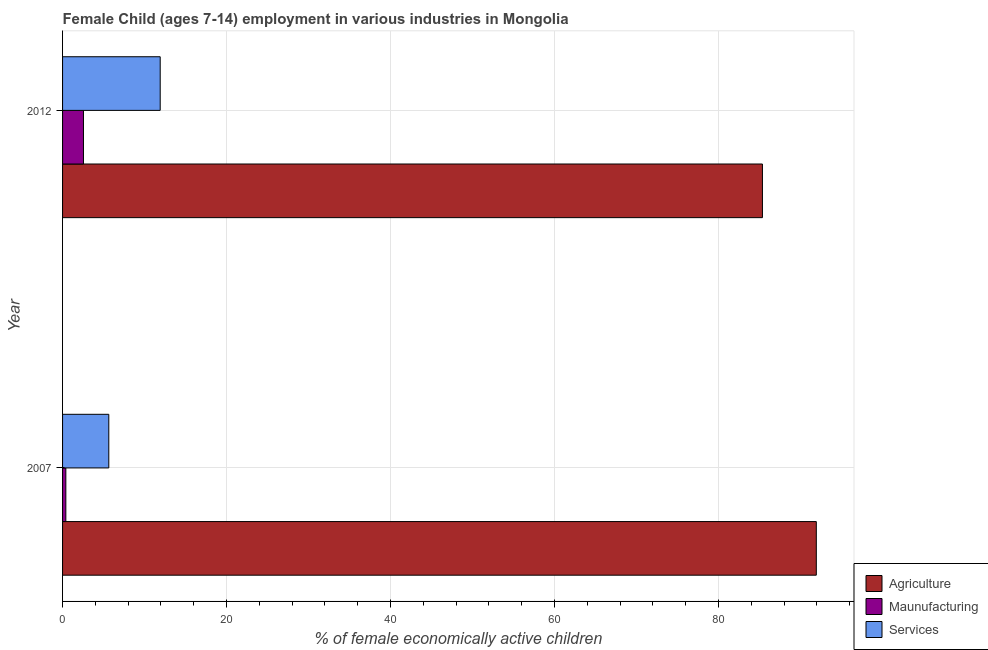Are the number of bars per tick equal to the number of legend labels?
Ensure brevity in your answer.  Yes. Are the number of bars on each tick of the Y-axis equal?
Provide a succinct answer. Yes. How many bars are there on the 1st tick from the bottom?
Your response must be concise. 3. What is the label of the 1st group of bars from the top?
Offer a very short reply. 2012. What is the percentage of economically active children in services in 2012?
Ensure brevity in your answer.  11.91. Across all years, what is the maximum percentage of economically active children in agriculture?
Ensure brevity in your answer.  91.94. In which year was the percentage of economically active children in agriculture maximum?
Your response must be concise. 2007. What is the total percentage of economically active children in agriculture in the graph?
Your response must be concise. 177.31. What is the difference between the percentage of economically active children in manufacturing in 2007 and that in 2012?
Keep it short and to the point. -2.15. What is the difference between the percentage of economically active children in services in 2007 and the percentage of economically active children in manufacturing in 2012?
Offer a terse response. 3.09. What is the average percentage of economically active children in manufacturing per year?
Offer a terse response. 1.48. In the year 2007, what is the difference between the percentage of economically active children in services and percentage of economically active children in agriculture?
Your response must be concise. -86.3. In how many years, is the percentage of economically active children in agriculture greater than 60 %?
Give a very brief answer. 2. What is the ratio of the percentage of economically active children in manufacturing in 2007 to that in 2012?
Your answer should be very brief. 0.16. What does the 1st bar from the top in 2012 represents?
Give a very brief answer. Services. What does the 2nd bar from the bottom in 2012 represents?
Offer a terse response. Maunufacturing. How many years are there in the graph?
Your answer should be very brief. 2. What is the difference between two consecutive major ticks on the X-axis?
Provide a short and direct response. 20. Are the values on the major ticks of X-axis written in scientific E-notation?
Your response must be concise. No. How many legend labels are there?
Your response must be concise. 3. How are the legend labels stacked?
Offer a very short reply. Vertical. What is the title of the graph?
Your response must be concise. Female Child (ages 7-14) employment in various industries in Mongolia. Does "Ages 0-14" appear as one of the legend labels in the graph?
Ensure brevity in your answer.  No. What is the label or title of the X-axis?
Your response must be concise. % of female economically active children. What is the label or title of the Y-axis?
Offer a very short reply. Year. What is the % of female economically active children in Agriculture in 2007?
Offer a terse response. 91.94. What is the % of female economically active children in Maunufacturing in 2007?
Ensure brevity in your answer.  0.4. What is the % of female economically active children of Services in 2007?
Make the answer very short. 5.64. What is the % of female economically active children of Agriculture in 2012?
Give a very brief answer. 85.37. What is the % of female economically active children in Maunufacturing in 2012?
Your answer should be very brief. 2.55. What is the % of female economically active children in Services in 2012?
Provide a short and direct response. 11.91. Across all years, what is the maximum % of female economically active children of Agriculture?
Keep it short and to the point. 91.94. Across all years, what is the maximum % of female economically active children of Maunufacturing?
Provide a short and direct response. 2.55. Across all years, what is the maximum % of female economically active children in Services?
Provide a short and direct response. 11.91. Across all years, what is the minimum % of female economically active children of Agriculture?
Offer a terse response. 85.37. Across all years, what is the minimum % of female economically active children of Maunufacturing?
Your answer should be very brief. 0.4. Across all years, what is the minimum % of female economically active children in Services?
Your response must be concise. 5.64. What is the total % of female economically active children in Agriculture in the graph?
Provide a succinct answer. 177.31. What is the total % of female economically active children of Maunufacturing in the graph?
Make the answer very short. 2.95. What is the total % of female economically active children of Services in the graph?
Keep it short and to the point. 17.55. What is the difference between the % of female economically active children of Agriculture in 2007 and that in 2012?
Make the answer very short. 6.57. What is the difference between the % of female economically active children in Maunufacturing in 2007 and that in 2012?
Offer a very short reply. -2.15. What is the difference between the % of female economically active children of Services in 2007 and that in 2012?
Give a very brief answer. -6.27. What is the difference between the % of female economically active children in Agriculture in 2007 and the % of female economically active children in Maunufacturing in 2012?
Your answer should be very brief. 89.39. What is the difference between the % of female economically active children in Agriculture in 2007 and the % of female economically active children in Services in 2012?
Offer a terse response. 80.03. What is the difference between the % of female economically active children of Maunufacturing in 2007 and the % of female economically active children of Services in 2012?
Your answer should be compact. -11.51. What is the average % of female economically active children of Agriculture per year?
Ensure brevity in your answer.  88.66. What is the average % of female economically active children of Maunufacturing per year?
Provide a succinct answer. 1.48. What is the average % of female economically active children of Services per year?
Your answer should be very brief. 8.78. In the year 2007, what is the difference between the % of female economically active children of Agriculture and % of female economically active children of Maunufacturing?
Offer a terse response. 91.54. In the year 2007, what is the difference between the % of female economically active children of Agriculture and % of female economically active children of Services?
Keep it short and to the point. 86.3. In the year 2007, what is the difference between the % of female economically active children of Maunufacturing and % of female economically active children of Services?
Offer a terse response. -5.24. In the year 2012, what is the difference between the % of female economically active children of Agriculture and % of female economically active children of Maunufacturing?
Make the answer very short. 82.82. In the year 2012, what is the difference between the % of female economically active children in Agriculture and % of female economically active children in Services?
Give a very brief answer. 73.46. In the year 2012, what is the difference between the % of female economically active children in Maunufacturing and % of female economically active children in Services?
Your answer should be very brief. -9.36. What is the ratio of the % of female economically active children in Agriculture in 2007 to that in 2012?
Make the answer very short. 1.08. What is the ratio of the % of female economically active children of Maunufacturing in 2007 to that in 2012?
Your response must be concise. 0.16. What is the ratio of the % of female economically active children of Services in 2007 to that in 2012?
Keep it short and to the point. 0.47. What is the difference between the highest and the second highest % of female economically active children in Agriculture?
Offer a terse response. 6.57. What is the difference between the highest and the second highest % of female economically active children in Maunufacturing?
Offer a terse response. 2.15. What is the difference between the highest and the second highest % of female economically active children in Services?
Make the answer very short. 6.27. What is the difference between the highest and the lowest % of female economically active children of Agriculture?
Your answer should be very brief. 6.57. What is the difference between the highest and the lowest % of female economically active children of Maunufacturing?
Your answer should be compact. 2.15. What is the difference between the highest and the lowest % of female economically active children in Services?
Your response must be concise. 6.27. 